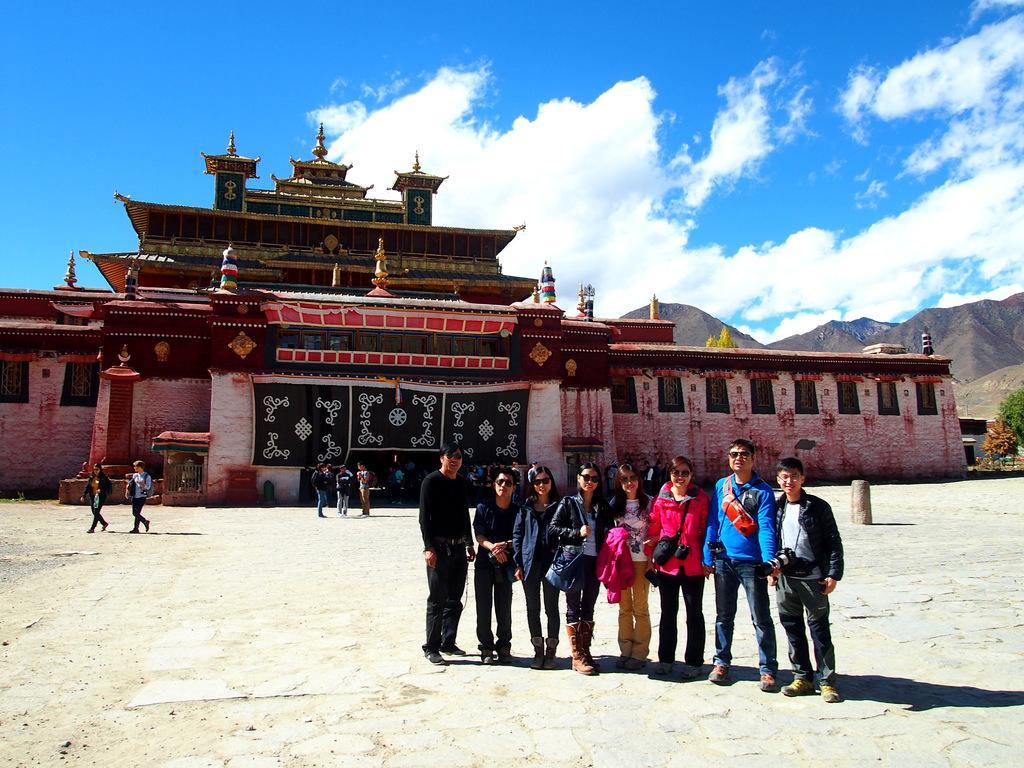Describe this image in one or two sentences. In this picture I can see group of people standing, there is a building, there are trees, mountains, and in the background there is sky. 